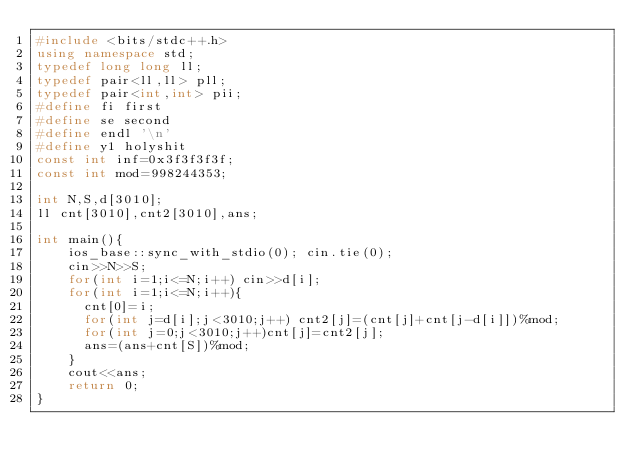<code> <loc_0><loc_0><loc_500><loc_500><_C++_>#include <bits/stdc++.h>
using namespace std;
typedef long long ll;
typedef pair<ll,ll> pll;
typedef pair<int,int> pii;
#define fi first
#define se second
#define endl '\n'
#define y1 holyshit
const int inf=0x3f3f3f3f;
const int mod=998244353;

int N,S,d[3010];
ll cnt[3010],cnt2[3010],ans;

int main(){
    ios_base::sync_with_stdio(0); cin.tie(0);
    cin>>N>>S;
    for(int i=1;i<=N;i++) cin>>d[i];
    for(int i=1;i<=N;i++){
    	cnt[0]=i;
    	for(int j=d[i];j<3010;j++) cnt2[j]=(cnt[j]+cnt[j-d[i]])%mod;
    	for(int j=0;j<3010;j++)cnt[j]=cnt2[j];
    	ans=(ans+cnt[S])%mod;
    }
    cout<<ans;
    return 0;
}</code> 